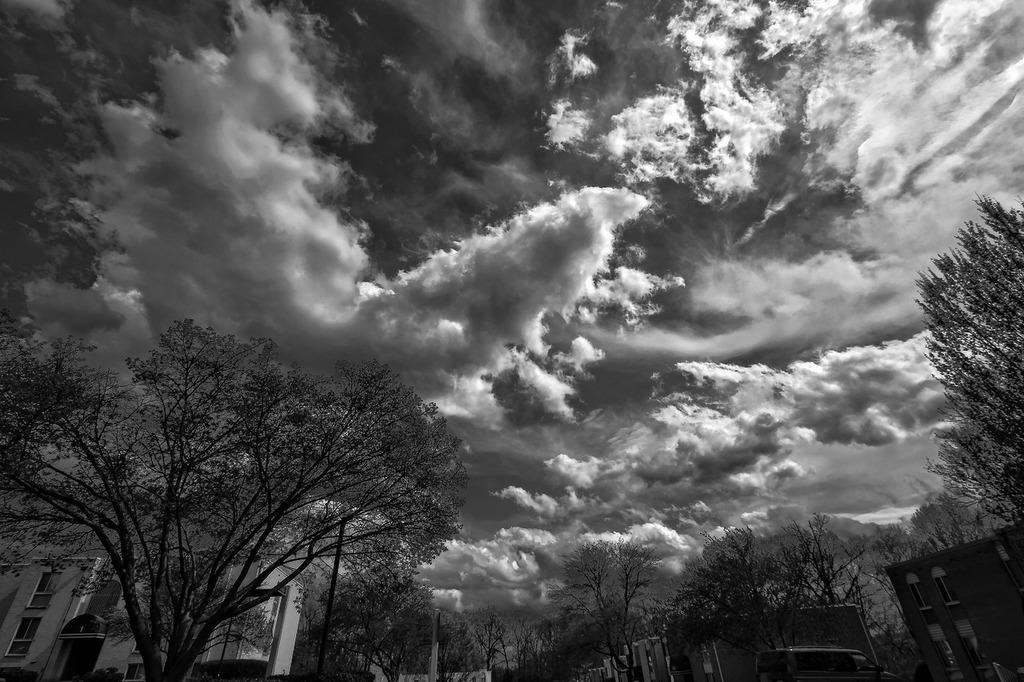What type of vegetation is at the bottom of the image? There are trees at the bottom of the image. What structure is located on the left side of the image? There is a building on the left side of the image. What is visible at the top of the image? The sky is visible at the top of the image. What can be seen in the sky in the image? Clouds are present in the sky. What theory is being discussed in the image? There is no discussion or theories present in the image. --- Facts: 1. There is a car in the image. 2. The car is red. 3. The car has four wheels. 4. The car is parked on the street. 5. There are people walking on the sidewalk. Absurd Topics: elephant, piano, ocean Conversation: What type of vehicle is in the image? There is a car in the image. What color is the car in the image? The car is red in the image. How many wheels does the car have in the image? The car has four wheels in the image. Where is the car located in the image? The car is parked on the street in the image. What else can be seen in the image? There are people walking on the sidewalk in the image. Reasoning: Let's think step by step in order to produce the conversation. We start by identifying the main subject in the image, which is the car. Then, we describe specific features of the car, such as its color and the number of wheels it has. Next, we observe the car's location in the image, which is parked on the street. Finally, we describe any additional elements present in the image, which in this case are the people walking on the sidewalk. Absurd Question/Answer: Can you hear the elephant playing the piano by the ocean in the image? There is no elephant, piano, or ocean present in the image. 